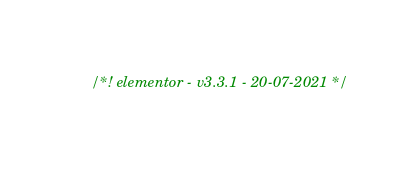Convert code to text. <code><loc_0><loc_0><loc_500><loc_500><_CSS_>/*! elementor - v3.3.1 - 20-07-2021 */</code> 